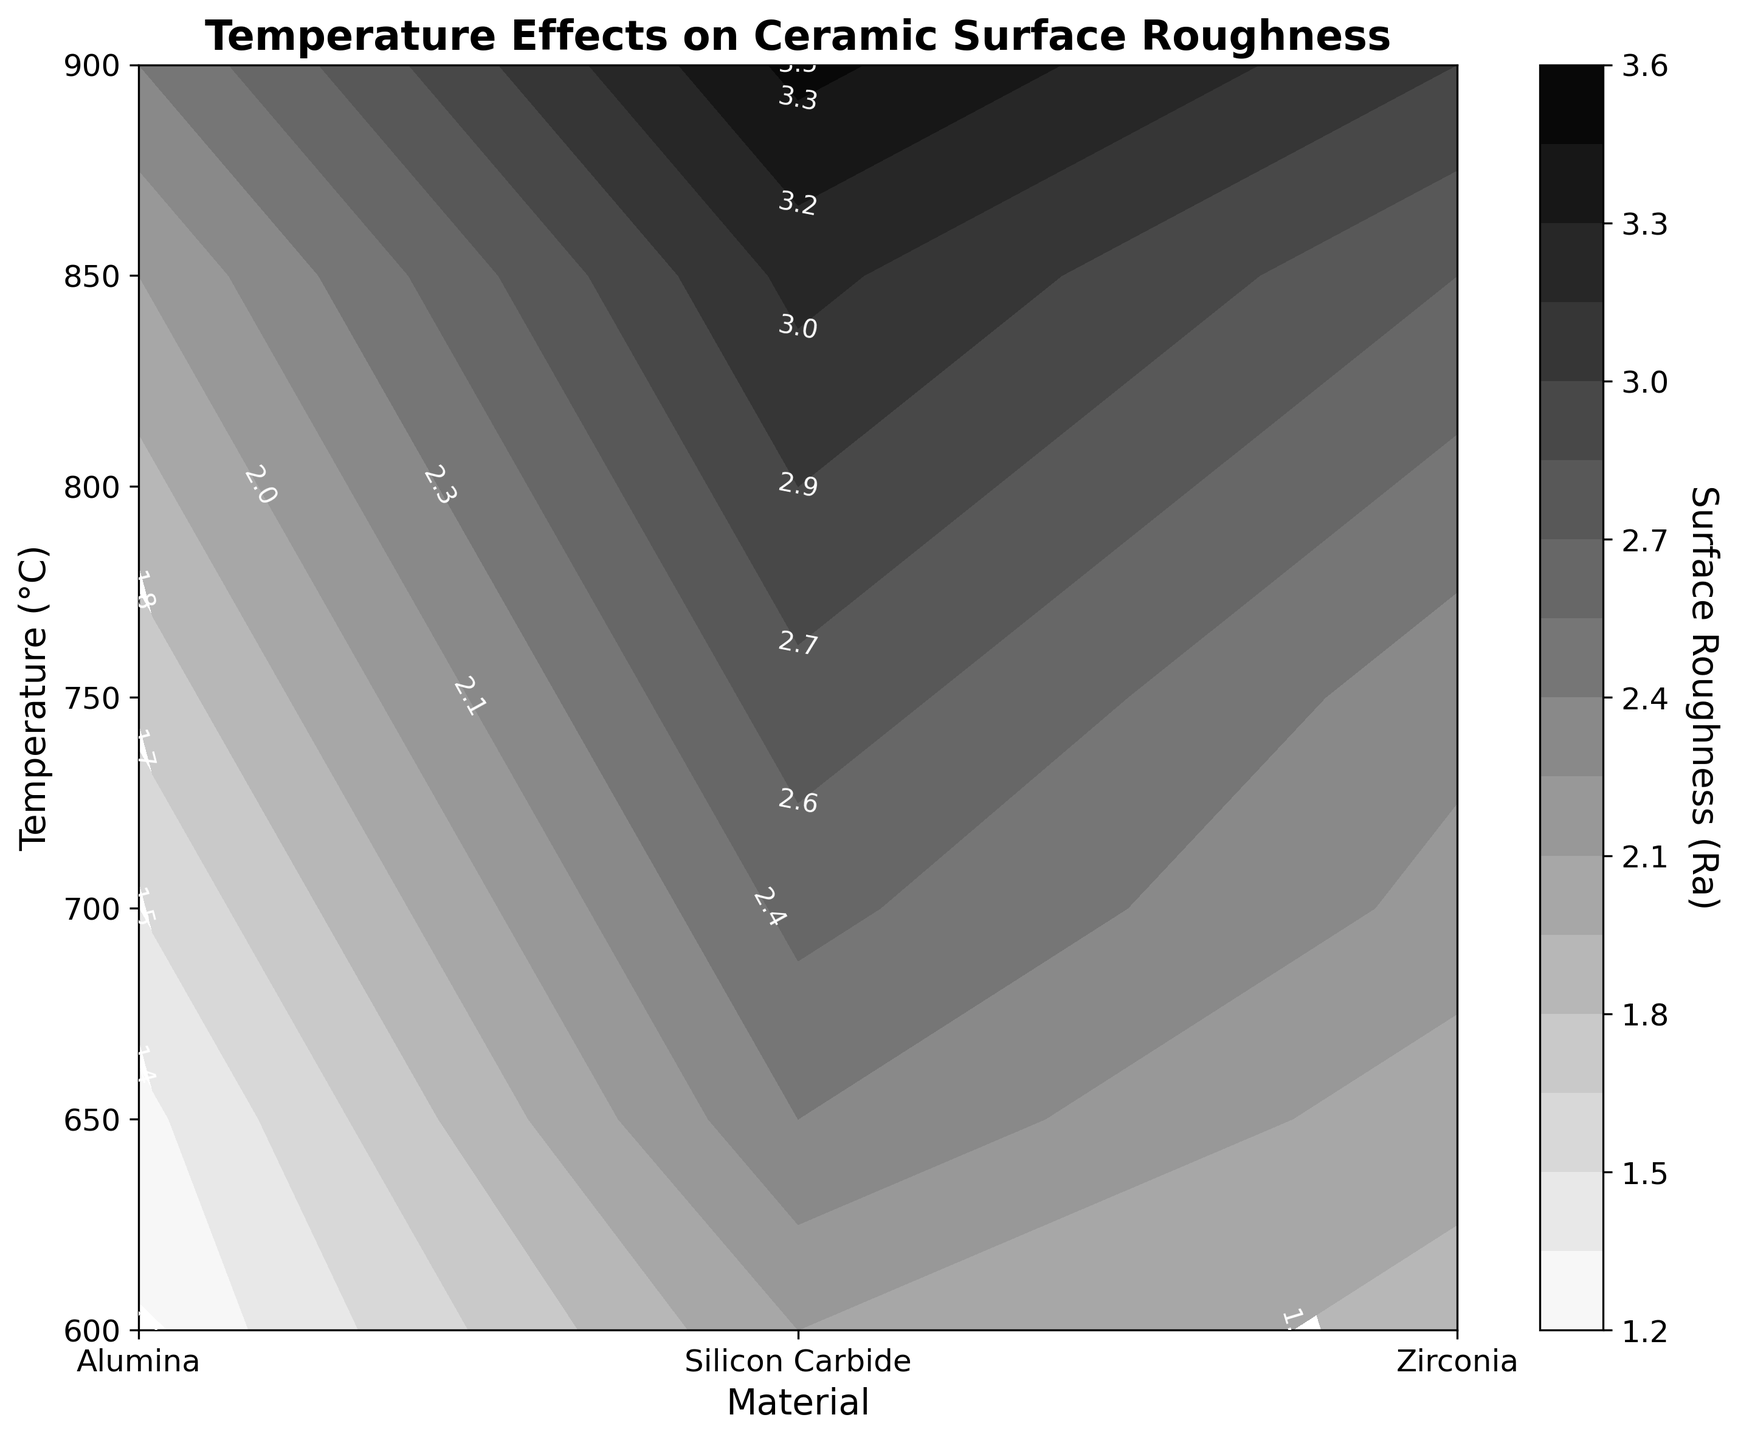What's the title of the figure? The title of the figure is usually located at the top of the plot area. In this case, it reads 'Temperature Effects on Ceramic Surface Roughness'.
Answer: Temperature Effects on Ceramic Surface Roughness Which material shows the highest surface roughness at 850°C? To answer this, one should locate the contour at 850°C on the y-axis and trace horizontally to find the highest value of surface roughness (Ra) among the materials. Silicon Carbide shows the highest surface roughness at 850°C.
Answer: Silicon Carbide What's the general trend of surface roughness in Alumina as temperature increases? Observing the contour plot shows how the surface roughness (Ra) of Alumina changes along the temperature axis. The general trend indicates an increase in surface roughness of Alumina as temperature increases.
Answer: Increases How does the surface roughness of Silicon Carbide at 750°C compare to that at 800°C? Locate Silicon Carbide in the legend and check the contour levels at 750°C and 800°C. At 750°C, Silicon Carbide has a surface roughness (Ra) of 2.8, and at 800°C, it increases to 3.0.
Answer: It increases Which material displays the least variation in surface roughness across the temperature range? To determine the variation in surface roughness, one could track the range of Ra values for each material. Alumina shows the least variation as its Ra increases more slowly when compared to Silicon Carbide and Zirconia.
Answer: Alumina At what temperature does Zirconia first exhibit a surface roughness above 2.0 Ra? Starting from the contour level where Zirconia crosses the 2.0 Ra, it's observed between 650°C and 700°C.
Answer: 700°C If you average the surface roughness of Alumina between 750°C and 900°C, what is the result? To find this average, sum the Ra values for Alumina at these temperatures and divide by the number of temperatures: (1.7 + 1.9 + 2.1 + 2.4)/4 = 2.025
Answer: 2.0 Comparing at 600°C, which material has the lowest surface roughness? At 600°C, identify and compare the Ra values of each material on the contour: 1.2 for Alumina, 2.1 for Silicon Carbide, and 1.9 for Zirconia. Alumina has the lowest surface roughness.
Answer: Alumina What is the color gradient used in the contour plot? The plot uses a grayscale color gradient where white represents the lowest surface roughness and black represents the highest.
Answer: Grayscale from white to black What can be said about the behavior of surface roughness for materials when temperatures exceed 850°C? Observing the contour plot for all materials when temperatures exceed 850°C, surface roughness continues to increase across the board. Silicon Carbide shows the highest increment, while Alumina’s is the smallest increment.
Answer: Increases for all materials 